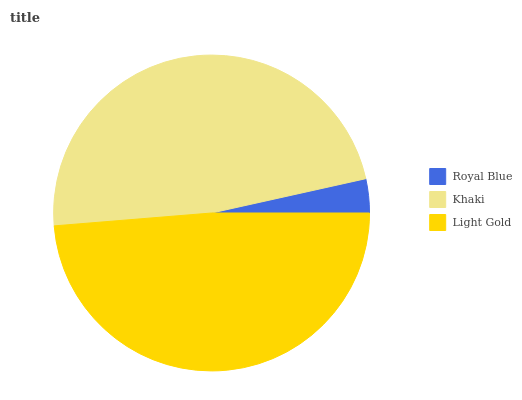Is Royal Blue the minimum?
Answer yes or no. Yes. Is Light Gold the maximum?
Answer yes or no. Yes. Is Khaki the minimum?
Answer yes or no. No. Is Khaki the maximum?
Answer yes or no. No. Is Khaki greater than Royal Blue?
Answer yes or no. Yes. Is Royal Blue less than Khaki?
Answer yes or no. Yes. Is Royal Blue greater than Khaki?
Answer yes or no. No. Is Khaki less than Royal Blue?
Answer yes or no. No. Is Khaki the high median?
Answer yes or no. Yes. Is Khaki the low median?
Answer yes or no. Yes. Is Royal Blue the high median?
Answer yes or no. No. Is Royal Blue the low median?
Answer yes or no. No. 